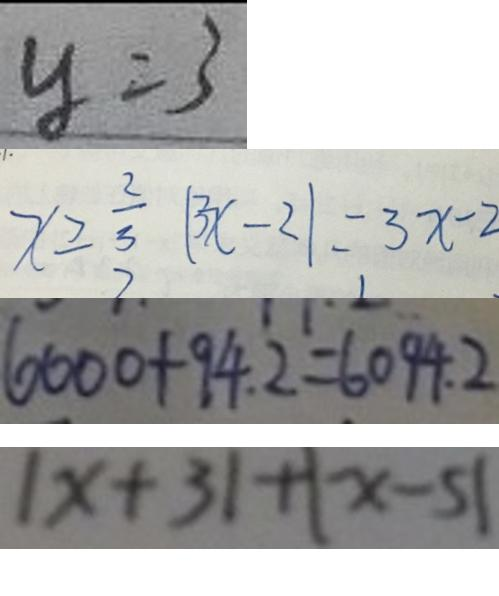Convert formula to latex. <formula><loc_0><loc_0><loc_500><loc_500>y = 3 
 x \geq \frac { 2 } { 3 } \vert 3 x - 2 \vert = 3 x - 2 
 6 0 0 0 + 9 4 . 2 = 6 0 9 4 . 2 
 \vert x + 3 \vert + \vert x - 5 \vert</formula> 